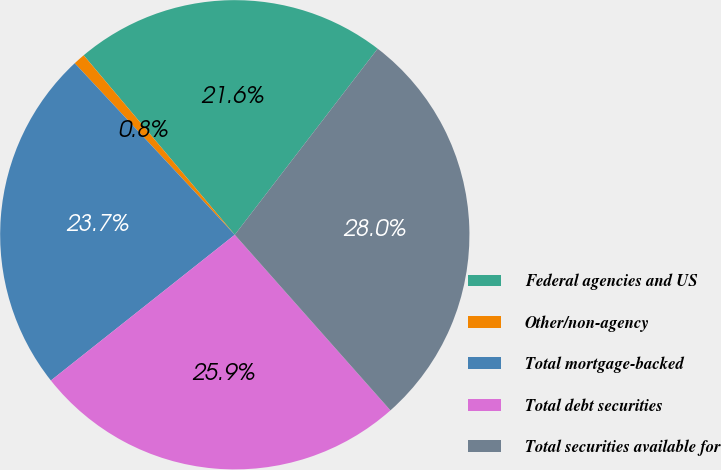Convert chart to OTSL. <chart><loc_0><loc_0><loc_500><loc_500><pie_chart><fcel>Federal agencies and US<fcel>Other/non-agency<fcel>Total mortgage-backed<fcel>Total debt securities<fcel>Total securities available for<nl><fcel>21.56%<fcel>0.81%<fcel>23.72%<fcel>25.88%<fcel>28.04%<nl></chart> 